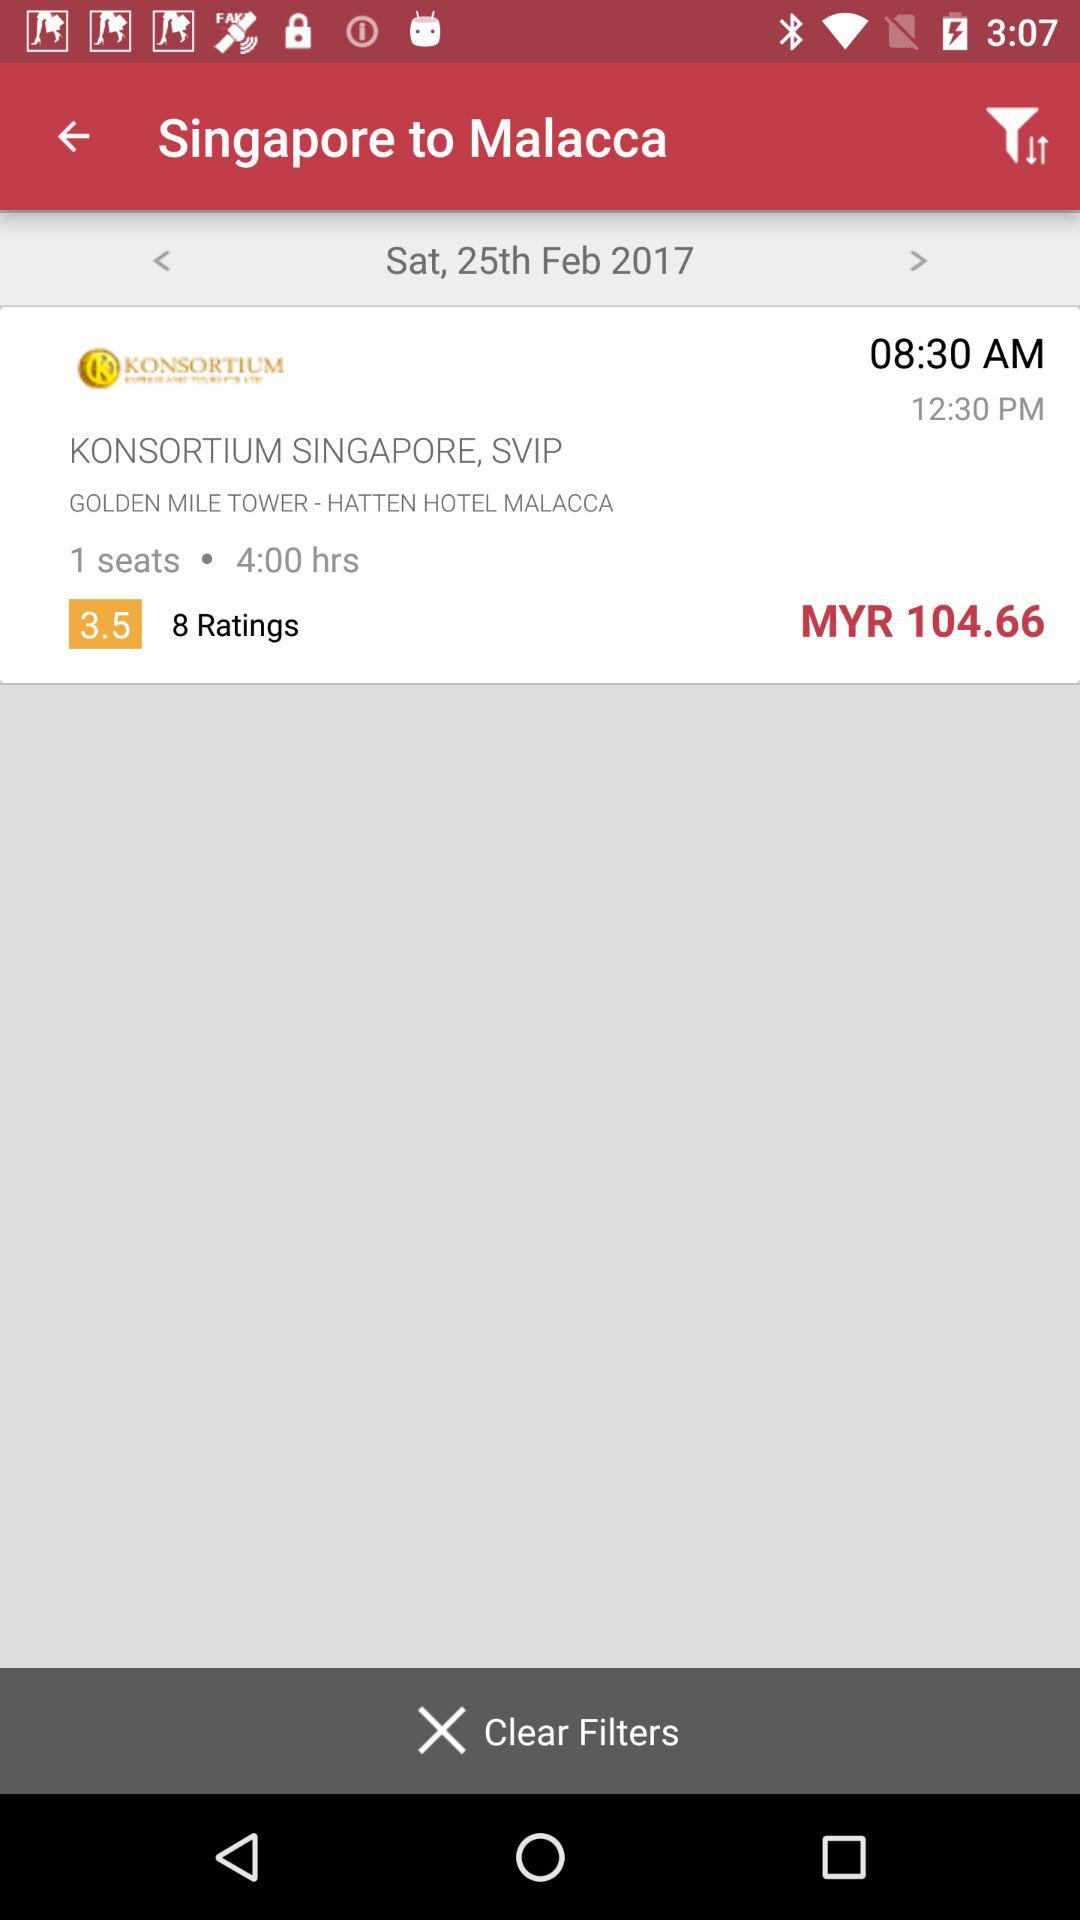What is the given duration? The given duration is 4 hours. 